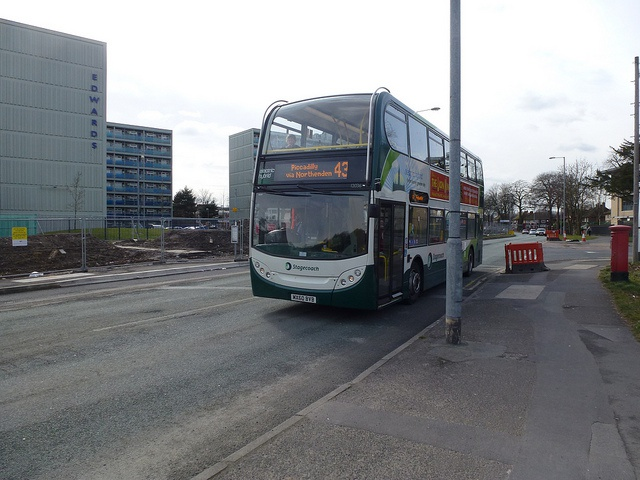Describe the objects in this image and their specific colors. I can see bus in white, black, gray, and darkgray tones, people in white and gray tones, car in white, black, gray, darkgray, and blue tones, car in white, black, gray, and darkgray tones, and car in white, gray, black, and darkgray tones in this image. 